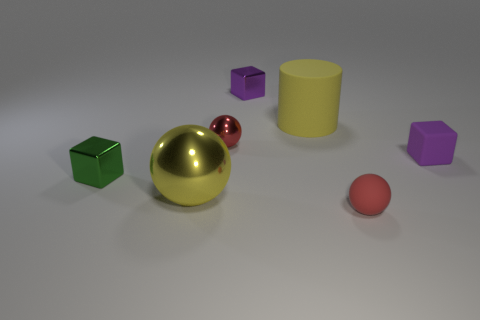Add 1 small red rubber things. How many objects exist? 8 Subtract all balls. How many objects are left? 4 Add 6 purple metallic cubes. How many purple metallic cubes exist? 7 Subtract 0 blue cubes. How many objects are left? 7 Subtract all big cylinders. Subtract all small matte cubes. How many objects are left? 5 Add 1 red objects. How many red objects are left? 3 